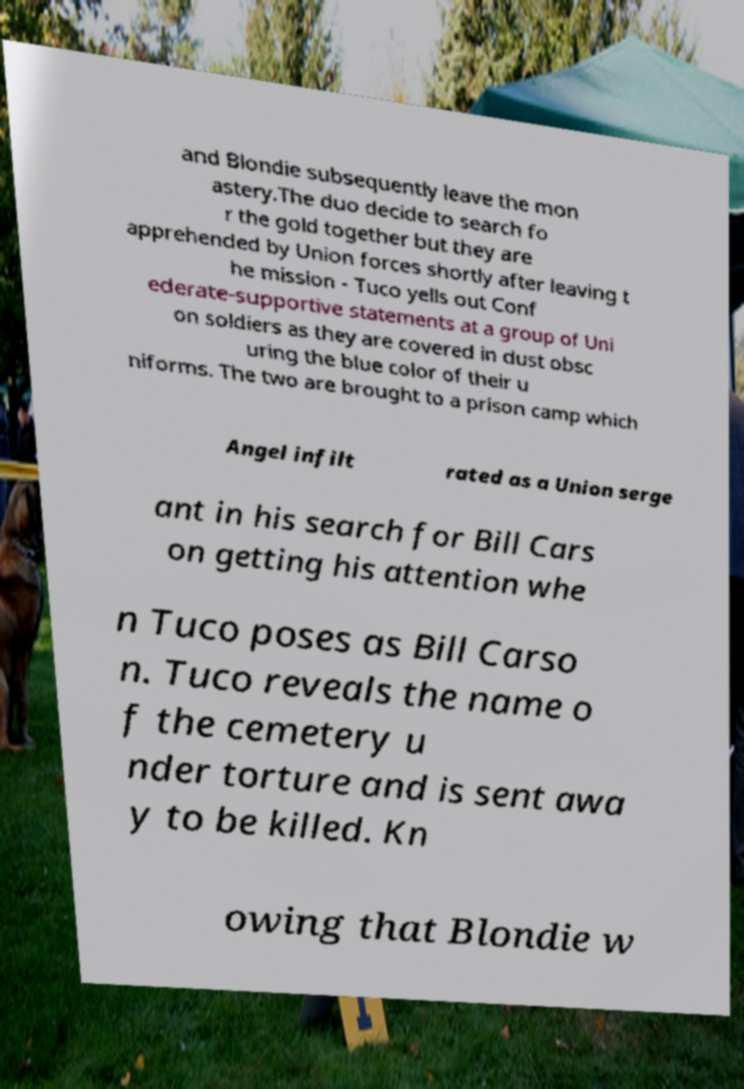Can you accurately transcribe the text from the provided image for me? and Blondie subsequently leave the mon astery.The duo decide to search fo r the gold together but they are apprehended by Union forces shortly after leaving t he mission - Tuco yells out Conf ederate-supportive statements at a group of Uni on soldiers as they are covered in dust obsc uring the blue color of their u niforms. The two are brought to a prison camp which Angel infilt rated as a Union serge ant in his search for Bill Cars on getting his attention whe n Tuco poses as Bill Carso n. Tuco reveals the name o f the cemetery u nder torture and is sent awa y to be killed. Kn owing that Blondie w 